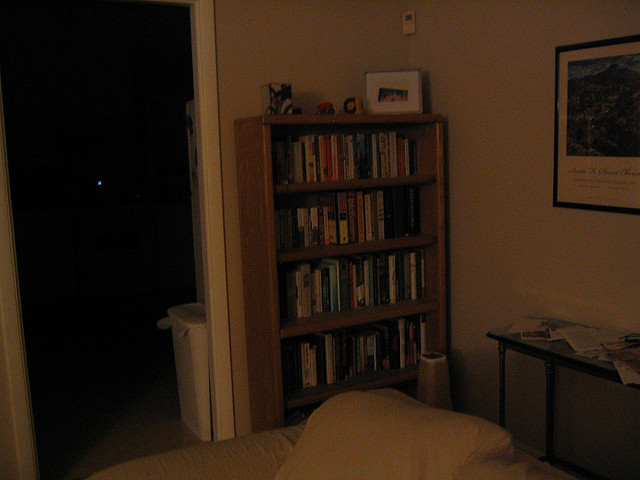<image>What brand shoe is the dog sitting on? The brand of the shoe the dog is sitting on is unknown. There is no visible shoe. Most of the books are about what animal? The primary subject of the books is not identifiable. However, they potentially could be about various animals such as dogs, pigs, tigers, cats or elephants. What is the color of the dog? There is no dog in the image. Is it daytime outside? It is ambiguous to determine if it's daytime outside. What is shown on the decals on the storage areas? It is unknown what is shown on the decals on the storage areas. It can be that there are no decals. Why is the desk so close to the sofa? It is ambiguous why the desk is so close to the sofa. It can be for convenience, decoration, or due to a small apartment. What brand shoe is the dog sitting on? It is unanswerable what brand shoe the dog is sitting on. There is no shoe visible in the image. What is the color of the dog? It is ambiguous what the color of the dog is. It can be seen as gray or black. Most of the books are about what animal? Most of the books are about animals. It can be seen books about dogs, pigs, tigers, cats, elephants. Is it daytime outside? It is unclear whether it is daytime outside. What is shown on the decals on the storage areas? There are no decals on the storage areas. Why is the desk so close to the sofa? I don't know why the desk is so close to the sofa. It could be for convenience, decoration, work, or because of the small apartment or small room. 